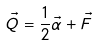<formula> <loc_0><loc_0><loc_500><loc_500>\vec { Q } = \frac { 1 } { 2 } \vec { \alpha } + \vec { F }</formula> 